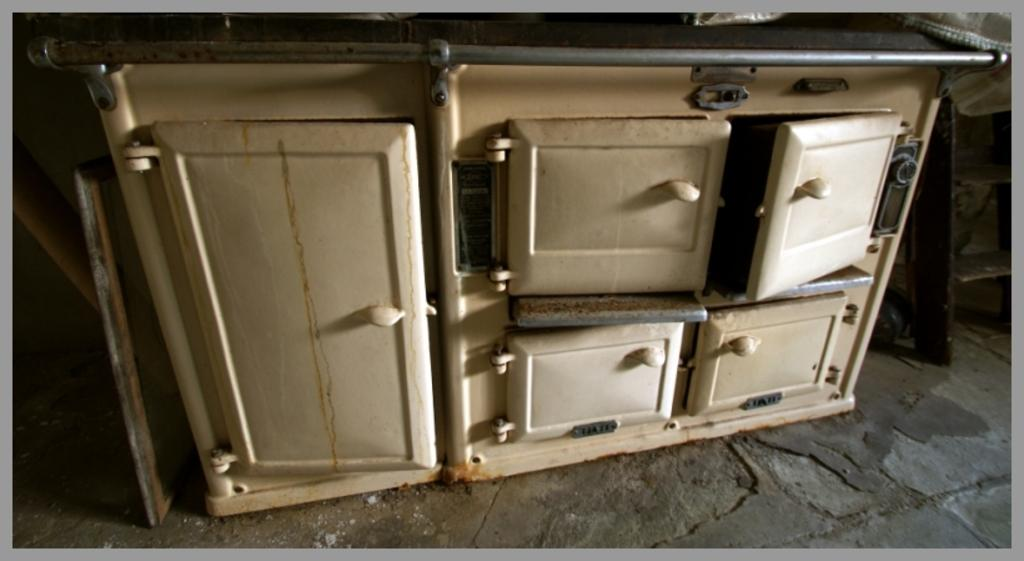What type of furniture is present in the image? There is a cupboard in the image. What else can be seen on the floor in the image? There are other objects on the floor in the image. How many clovers are growing on the road in the image? There is no road or clover present in the image. What type of bone can be seen in the image? There is no bone present in the image. 